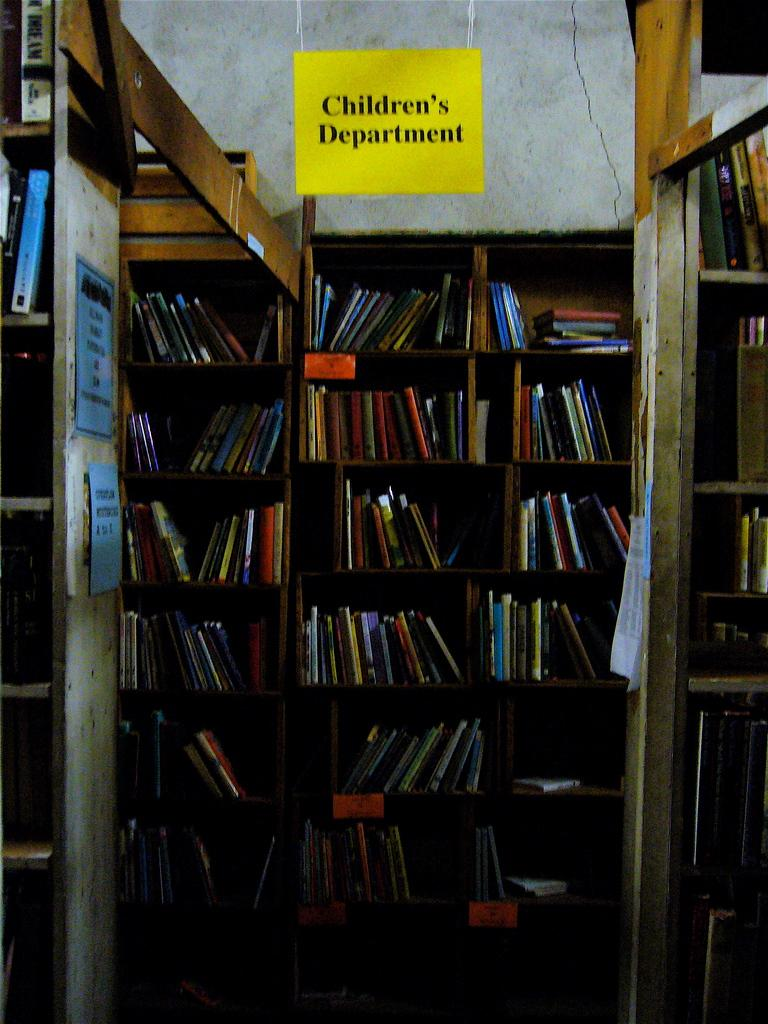Provide a one-sentence caption for the provided image. the bookcase is filled with a lot of books in a children section. 